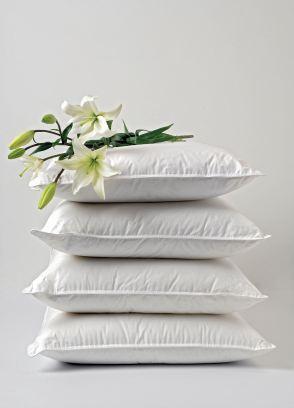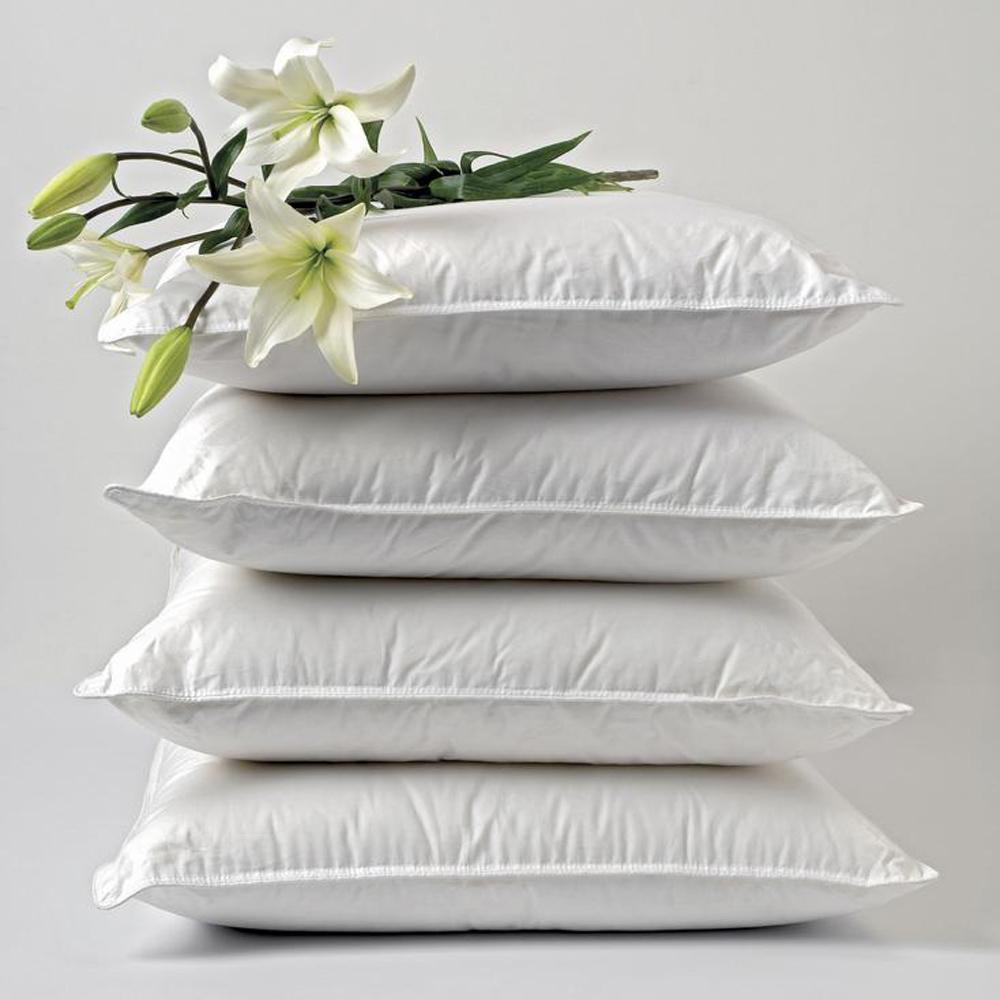The first image is the image on the left, the second image is the image on the right. Assess this claim about the two images: "One of the stacks has exactly three pillows and is decorated with ribbons and flowers.". Correct or not? Answer yes or no. No. 